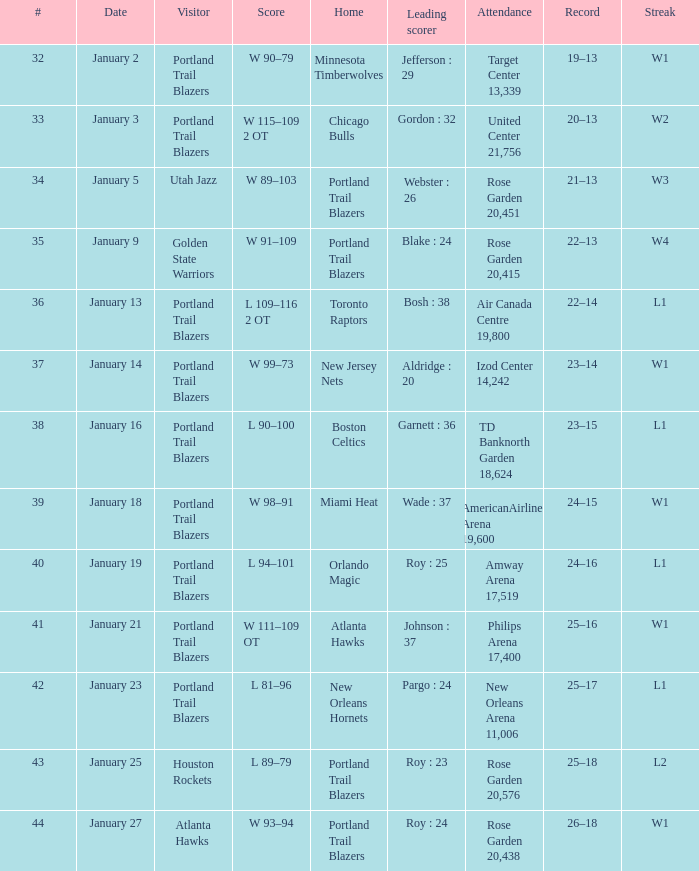Who are all the visitor with a record of 25–18 Houston Rockets. 